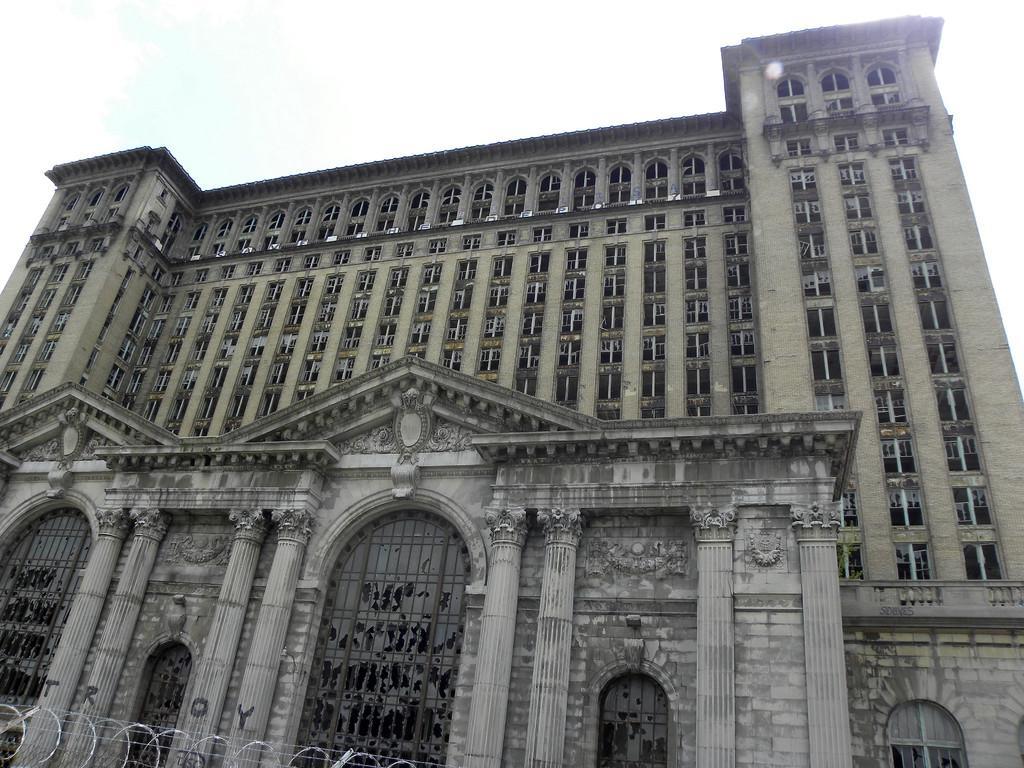Please provide a concise description of this image. In the center of the image, we can see a building and we can see some letters on the pillars and there is a fence. At the top, there is sky. 